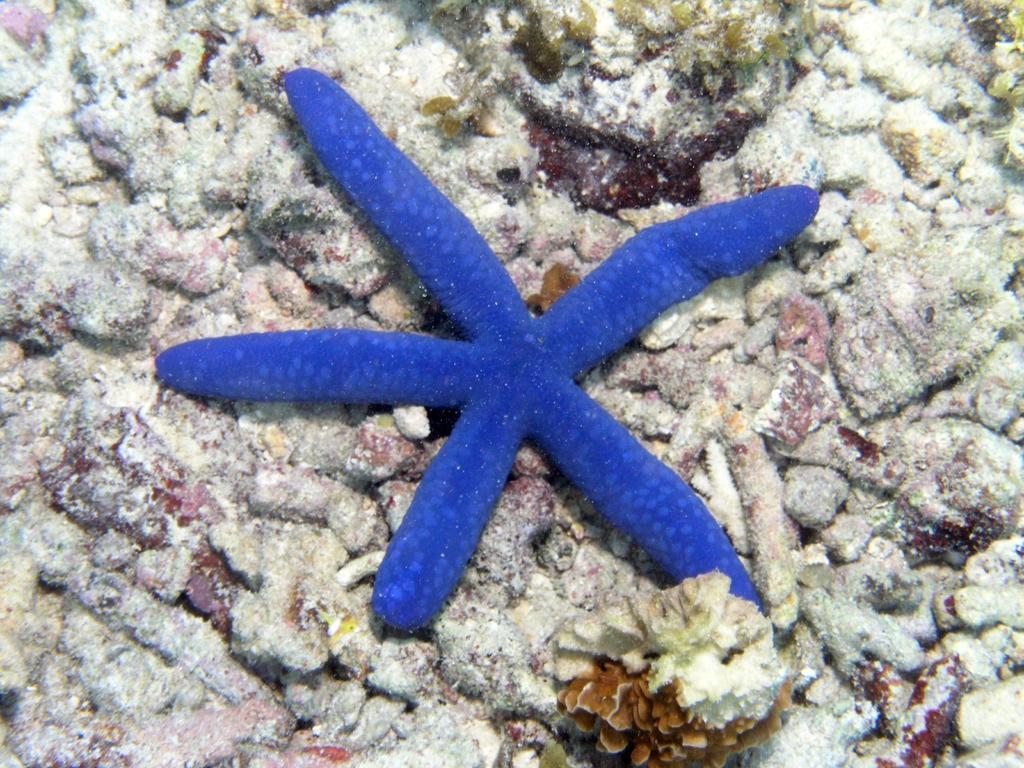Can you describe this image briefly? In this image I can see an aquatic animal in blue color. In the background I can see few stones. 